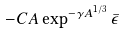<formula> <loc_0><loc_0><loc_500><loc_500>- C A \exp ^ { - \gamma A ^ { 1 / 3 } } \bar { \epsilon }</formula> 